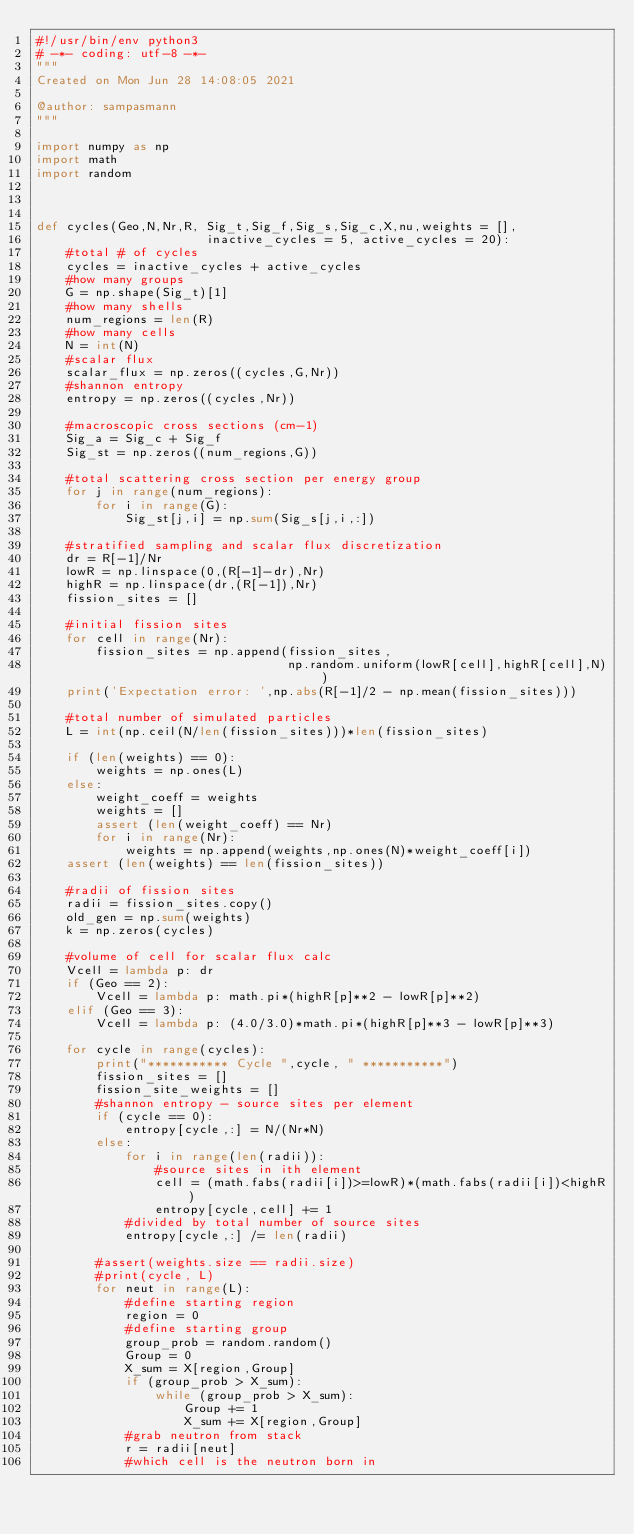Convert code to text. <code><loc_0><loc_0><loc_500><loc_500><_Python_>#!/usr/bin/env python3
# -*- coding: utf-8 -*-
"""
Created on Mon Jun 28 14:08:05 2021

@author: sampasmann
"""

import numpy as np
import math
import random



def cycles(Geo,N,Nr,R, Sig_t,Sig_f,Sig_s,Sig_c,X,nu,weights = [],
                       inactive_cycles = 5, active_cycles = 20):
    #total # of cycles
    cycles = inactive_cycles + active_cycles
    #how many groups
    G = np.shape(Sig_t)[1]
    #how many shells
    num_regions = len(R)
    #how many cells
    N = int(N)
    #scalar flux
    scalar_flux = np.zeros((cycles,G,Nr))
    #shannon entropy
    entropy = np.zeros((cycles,Nr))
    
    #macroscopic cross sections (cm-1)
    Sig_a = Sig_c + Sig_f
    Sig_st = np.zeros((num_regions,G))
    
    #total scattering cross section per energy group
    for j in range(num_regions):
        for i in range(G):
            Sig_st[j,i] = np.sum(Sig_s[j,i,:])
            
    #stratified sampling and scalar flux discretization
    dr = R[-1]/Nr
    lowR = np.linspace(0,(R[-1]-dr),Nr)
    highR = np.linspace(dr,(R[-1]),Nr)
    fission_sites = []

    #initial fission sites
    for cell in range(Nr):
        fission_sites = np.append(fission_sites,
                                  np.random.uniform(lowR[cell],highR[cell],N))
    print('Expectation error: ',np.abs(R[-1]/2 - np.mean(fission_sites)))
    
    #total number of simulated particles
    L = int(np.ceil(N/len(fission_sites)))*len(fission_sites)
    
    if (len(weights) == 0):
        weights = np.ones(L)
    else:
        weight_coeff = weights
        weights = []
        assert (len(weight_coeff) == Nr)
        for i in range(Nr):
            weights = np.append(weights,np.ones(N)*weight_coeff[i])
    assert (len(weights) == len(fission_sites))
    
    #radii of fission sites
    radii = fission_sites.copy()
    old_gen = np.sum(weights)
    k = np.zeros(cycles)
    
    #volume of cell for scalar flux calc
    Vcell = lambda p: dr
    if (Geo == 2):
        Vcell = lambda p: math.pi*(highR[p]**2 - lowR[p]**2)
    elif (Geo == 3):
        Vcell = lambda p: (4.0/3.0)*math.pi*(highR[p]**3 - lowR[p]**3)
    
    for cycle in range(cycles):
        print("*********** Cycle ",cycle, " ***********")
        fission_sites = []
        fission_site_weights = []
        #shannon entropy - source sites per element
        if (cycle == 0):
            entropy[cycle,:] = N/(Nr*N)
        else:
            for i in range(len(radii)):
                #source sites in ith element
                cell = (math.fabs(radii[i])>=lowR)*(math.fabs(radii[i])<highR)
                entropy[cycle,cell] += 1
            #divided by total number of source sites
            entropy[cycle,:] /= len(radii)
        
        #assert(weights.size == radii.size)
        #print(cycle, L)
        for neut in range(L):
            #define starting region 
            region = 0
            #define starting group
            group_prob = random.random()
            Group = 0
            X_sum = X[region,Group]
            if (group_prob > X_sum):
                while (group_prob > X_sum):
                    Group += 1
                    X_sum += X[region,Group]
            #grab neutron from stack
            r = radii[neut]
            #which cell is the neutron born in</code> 